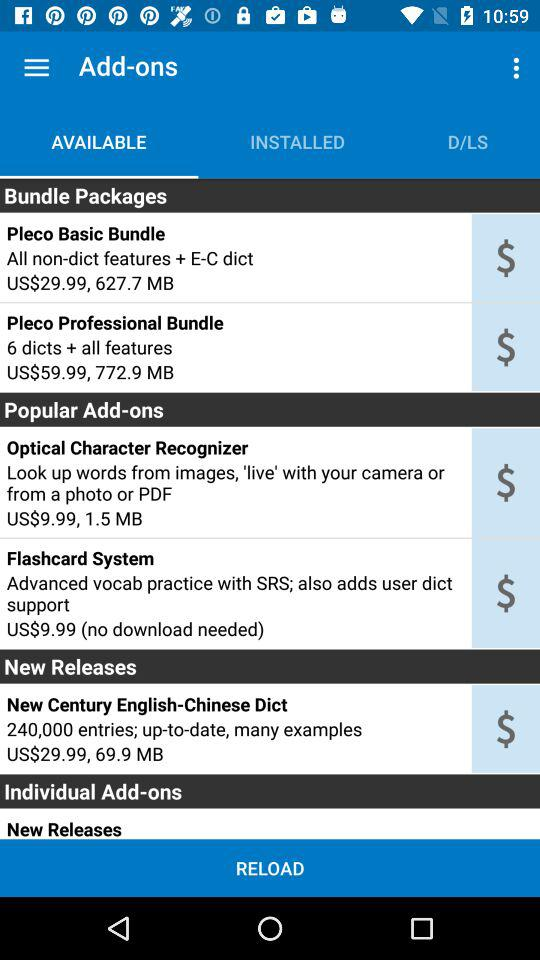What are the names of popular add-ons? The names of popular add-ons are "Optical Character Recognizer" and "Flashcard System". 